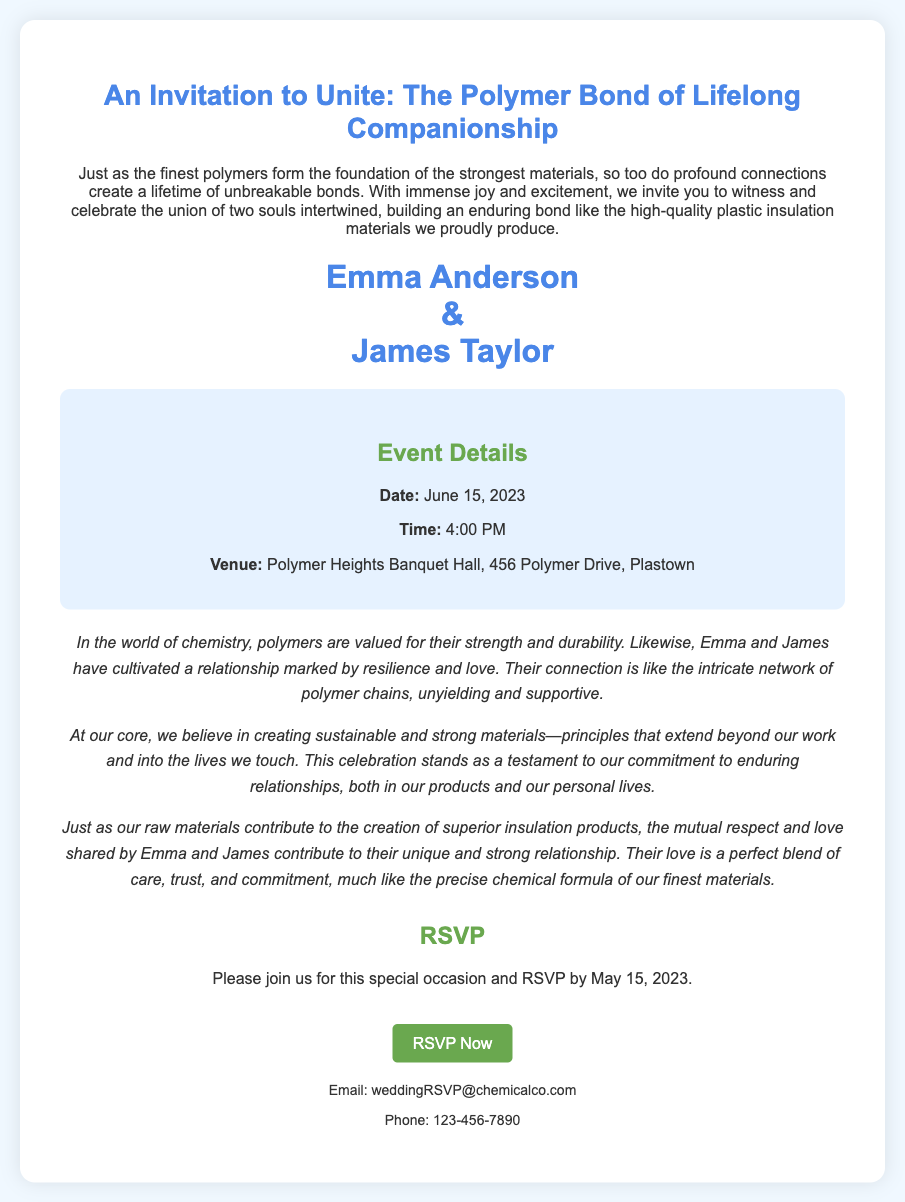What are the names of the couple? The names of the couple are listed prominently in the invitation.
Answer: Emma Anderson and James Taylor What is the date of the wedding? The document provides information about the date of the event clearly.
Answer: June 15, 2023 What time does the ceremony start? The start time for the wedding ceremony is specified in the event details.
Answer: 4:00 PM Where is the venue located? The venue address is provided in the event details, indicating where the event will take place.
Answer: Polymer Heights Banquet Hall, 456 Polymer Drive, Plastown What is the RSVP deadline? The document specifically mentions the last date for RSVP responses.
Answer: May 15, 2023 What thematic comparison does the invitation use? The invitation draws a thematic parallel between relationships and chemical elements.
Answer: Polymers What is highlighted about the couple's relationship? The document discusses the nature of the couple's relationship in terms of traits.
Answer: Resilience and love What type of event is being celebrated? The overall purpose of the document is to announce the celebration type.
Answer: A wedding 